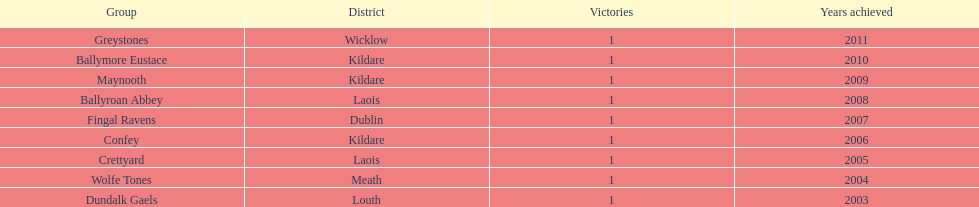What are the winning years for each team? 2011, 2010, 2009, 2008, 2007, 2006, 2005, 2004, 2003. 